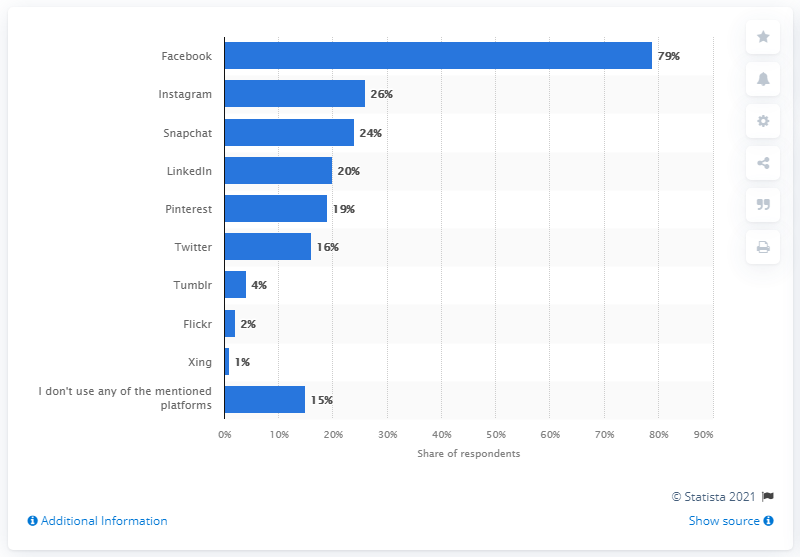Identify some key points in this picture. According to available data, Facebook was the most popular social network in Luxembourg in 2017. 